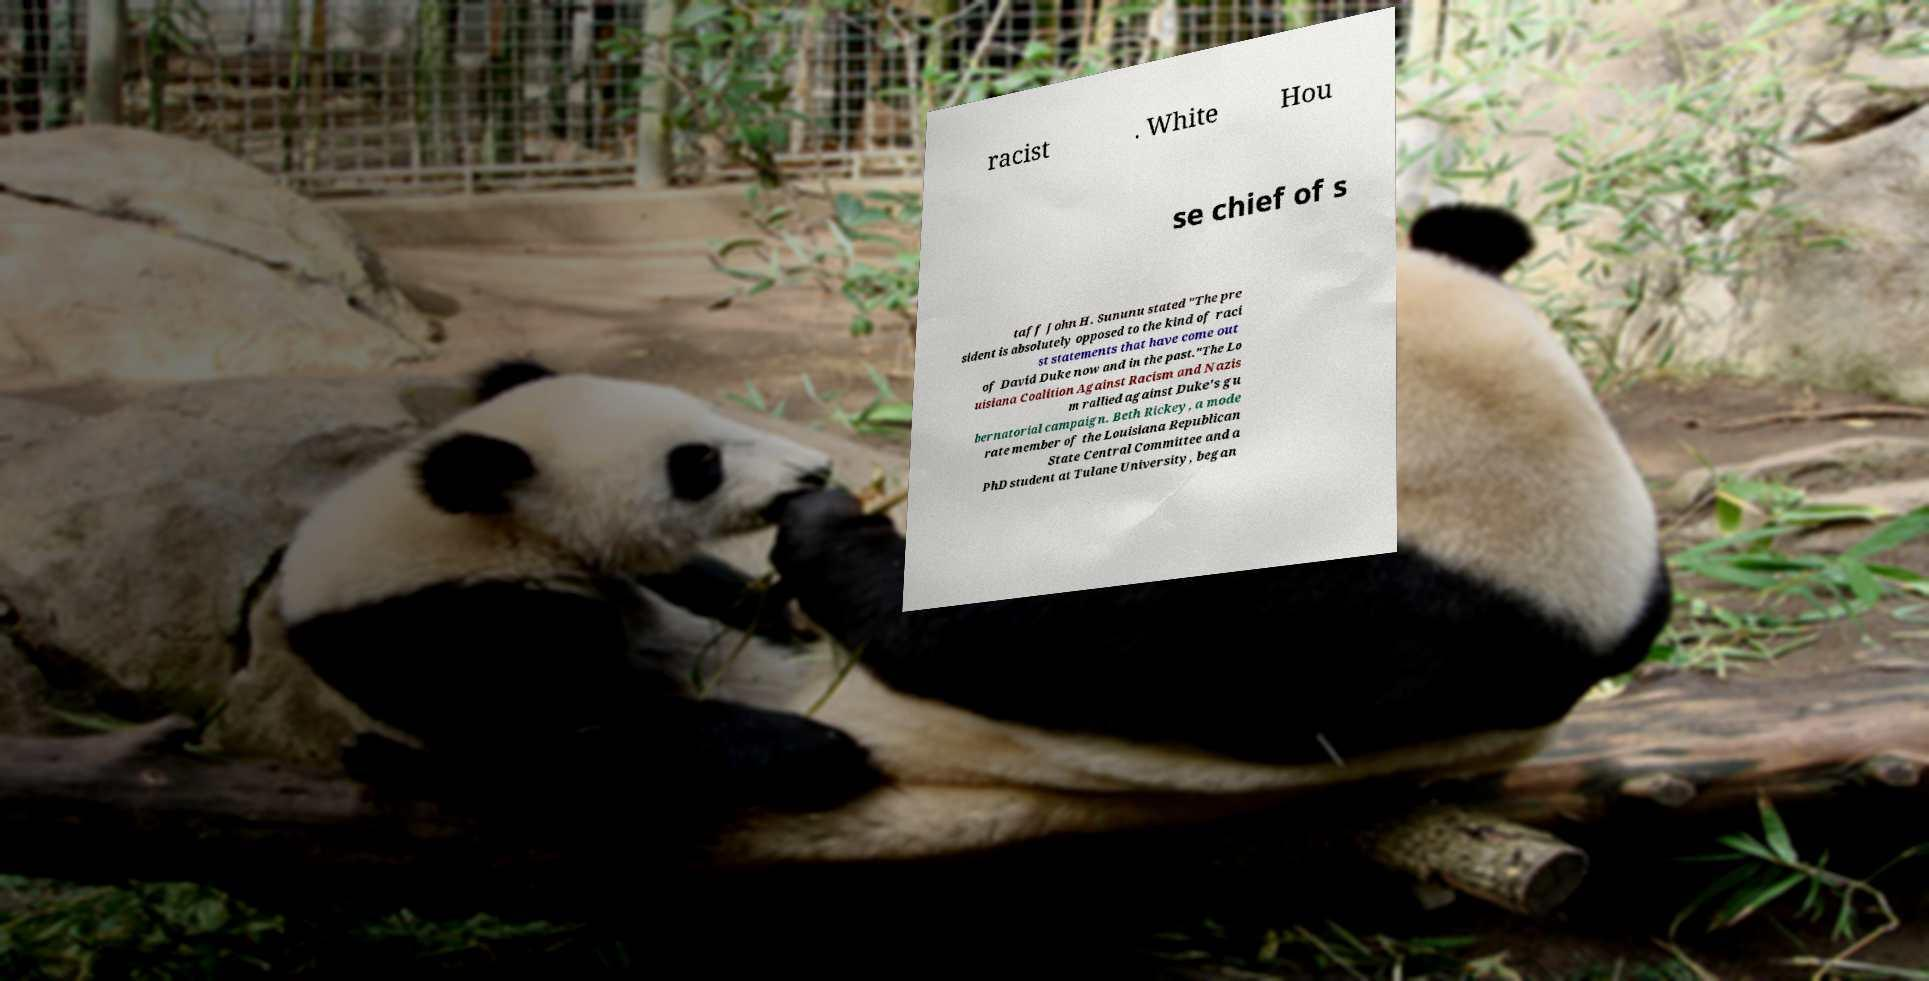Please read and relay the text visible in this image. What does it say? racist . White Hou se chief of s taff John H. Sununu stated "The pre sident is absolutely opposed to the kind of raci st statements that have come out of David Duke now and in the past."The Lo uisiana Coalition Against Racism and Nazis m rallied against Duke's gu bernatorial campaign. Beth Rickey, a mode rate member of the Louisiana Republican State Central Committee and a PhD student at Tulane University, began 